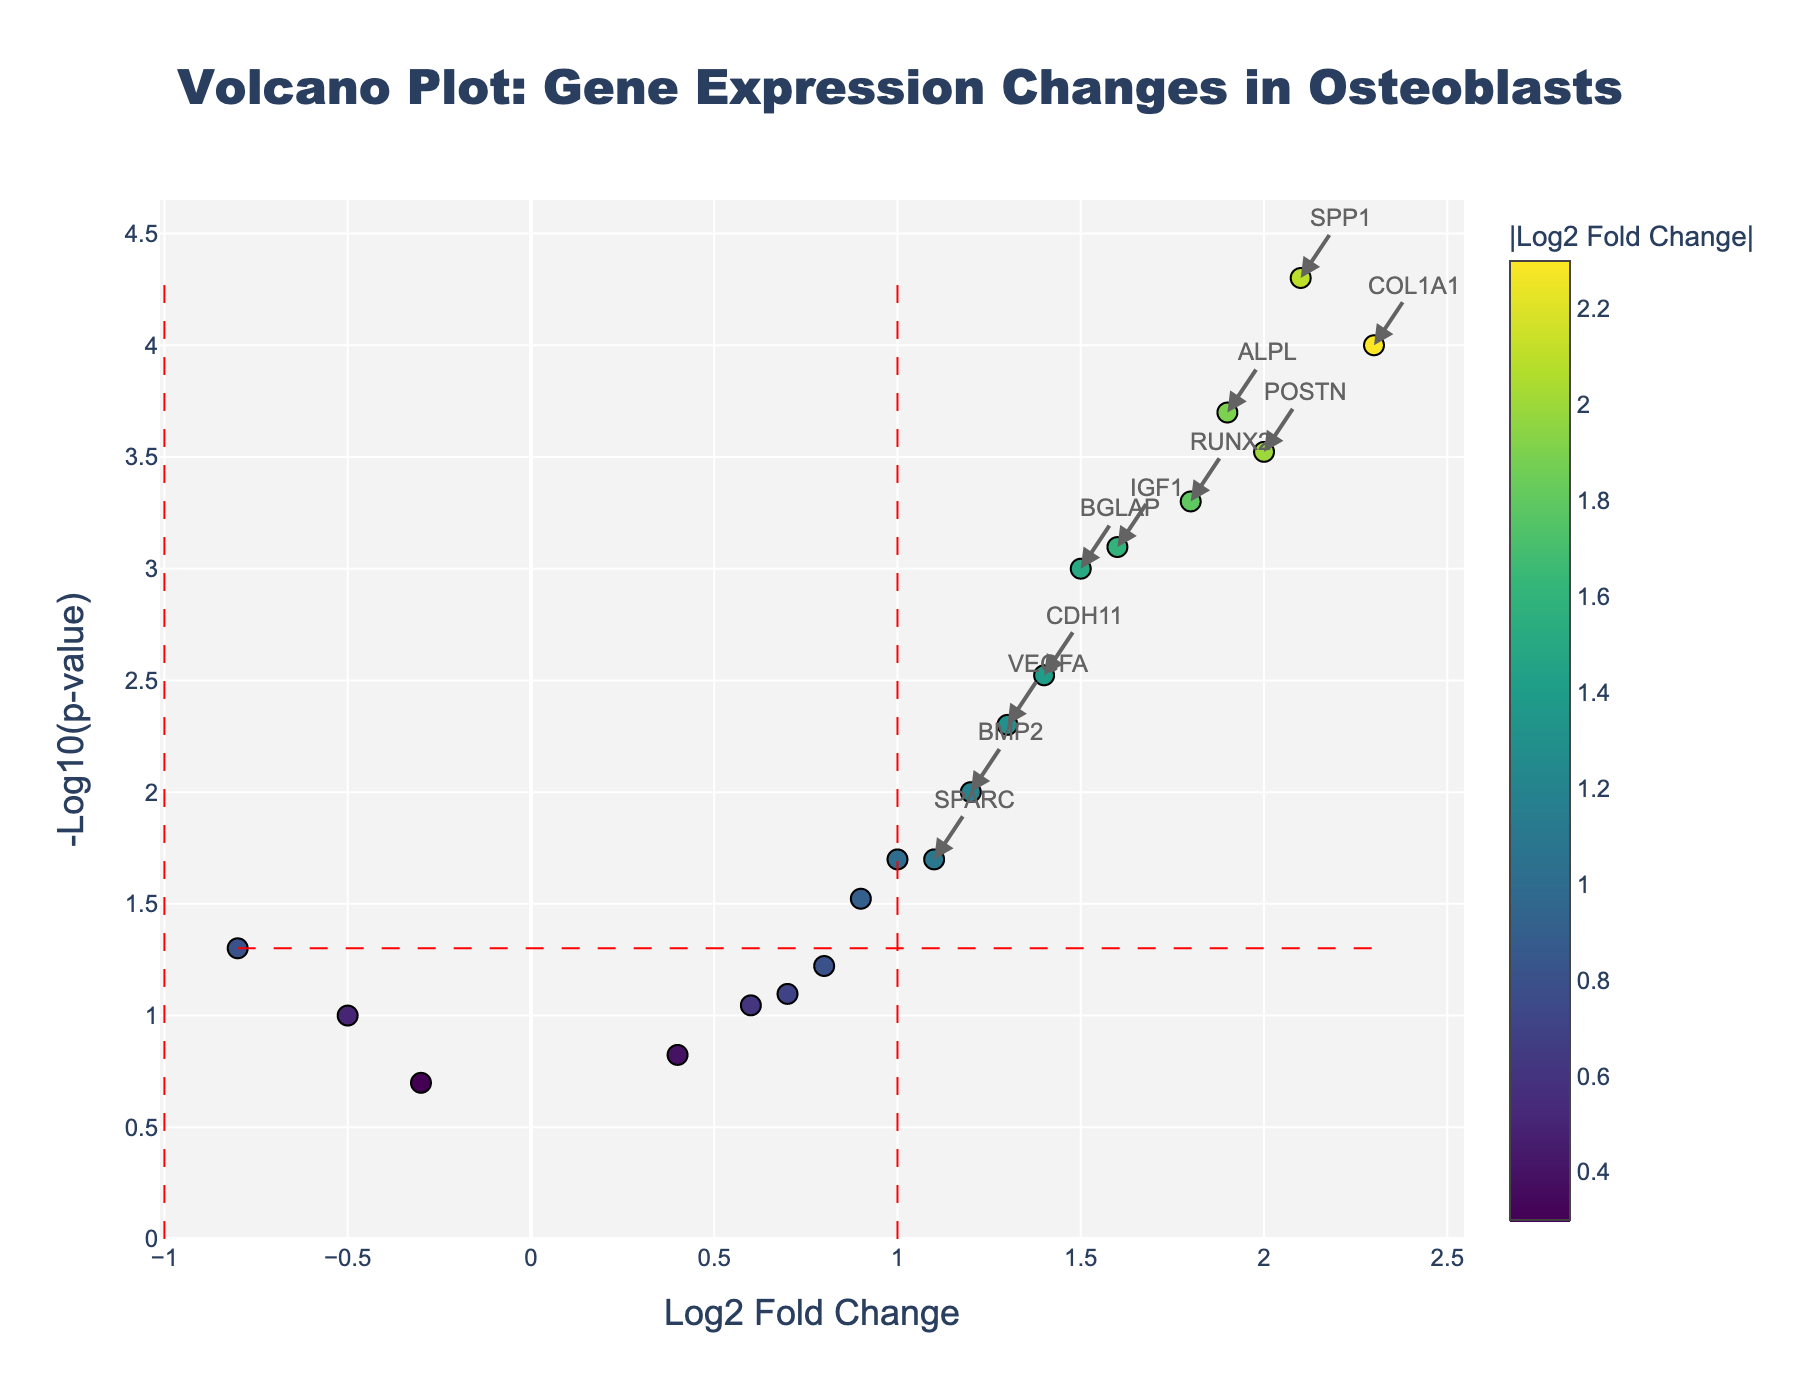How many genes exhibit a significant change in expression according to the plot? The visual information shows annotations on dots only for those genes that have significant changes. To answer this, count the number of annotated genes on the plot.
Answer: 10 What is the title of the Volcano Plot? The title is displayed at the top center of the plot. It provides a brief description of what the plot represents.
Answer: Volcano Plot: Gene Expression Changes in Osteoblasts Which gene shows the highest log2 fold change? To find the gene with the highest log2 fold change, look for the data point that is farthest to the right on the x-axis. The hover text or annotation typically provides the gene's name.
Answer: COL1A1 Which gene has the lowest -log10(p-value) among the significant genes? Among the significant genes annotated, find the one with the smallest y-value (closest to the x-axis). This represents the lowest -log10(p-value).
Answer: SPP1 How many genes have a p-value less than 0.05? Look at the significance line drawn horizontally at -log10(p)=1.301 (which corresponds to a p-value of 0.05). Count the number of data points above this line.
Answer: 12 How many genes show a log2 fold change greater than 1 and are significant (p-value < 0.05)? To answer this, identify the data points that lie to the right of the vertical significance line at log2 fold change = 1 and are also above the horizontal line at -log10(p)=1.301. Count these points.
Answer: 8 Which gene has a log2 fold change of approximately 1.9 and a significant p-value? Look for the data point located at log2 fold change ≈ 1.9. The hover text or annotation provides the gene's name.
Answer: ALPL Name the genes with a log2 fold change less than -0.5. Observe the data points positioned to the left of log2 fold change = -0.5 on the x-axis. Extract their names from the hover text or annotations.
Answer: IBSP, TNFRSF11B, FGFR1 What is the log2 fold change and p-value for the gene RUNX2? Locate the data point representing RUNX2 and note its position on the x and y axes or check the associated hover text for exact values.
Answer: Log2 Fold Change: 1.8, p-value: 0.0005 